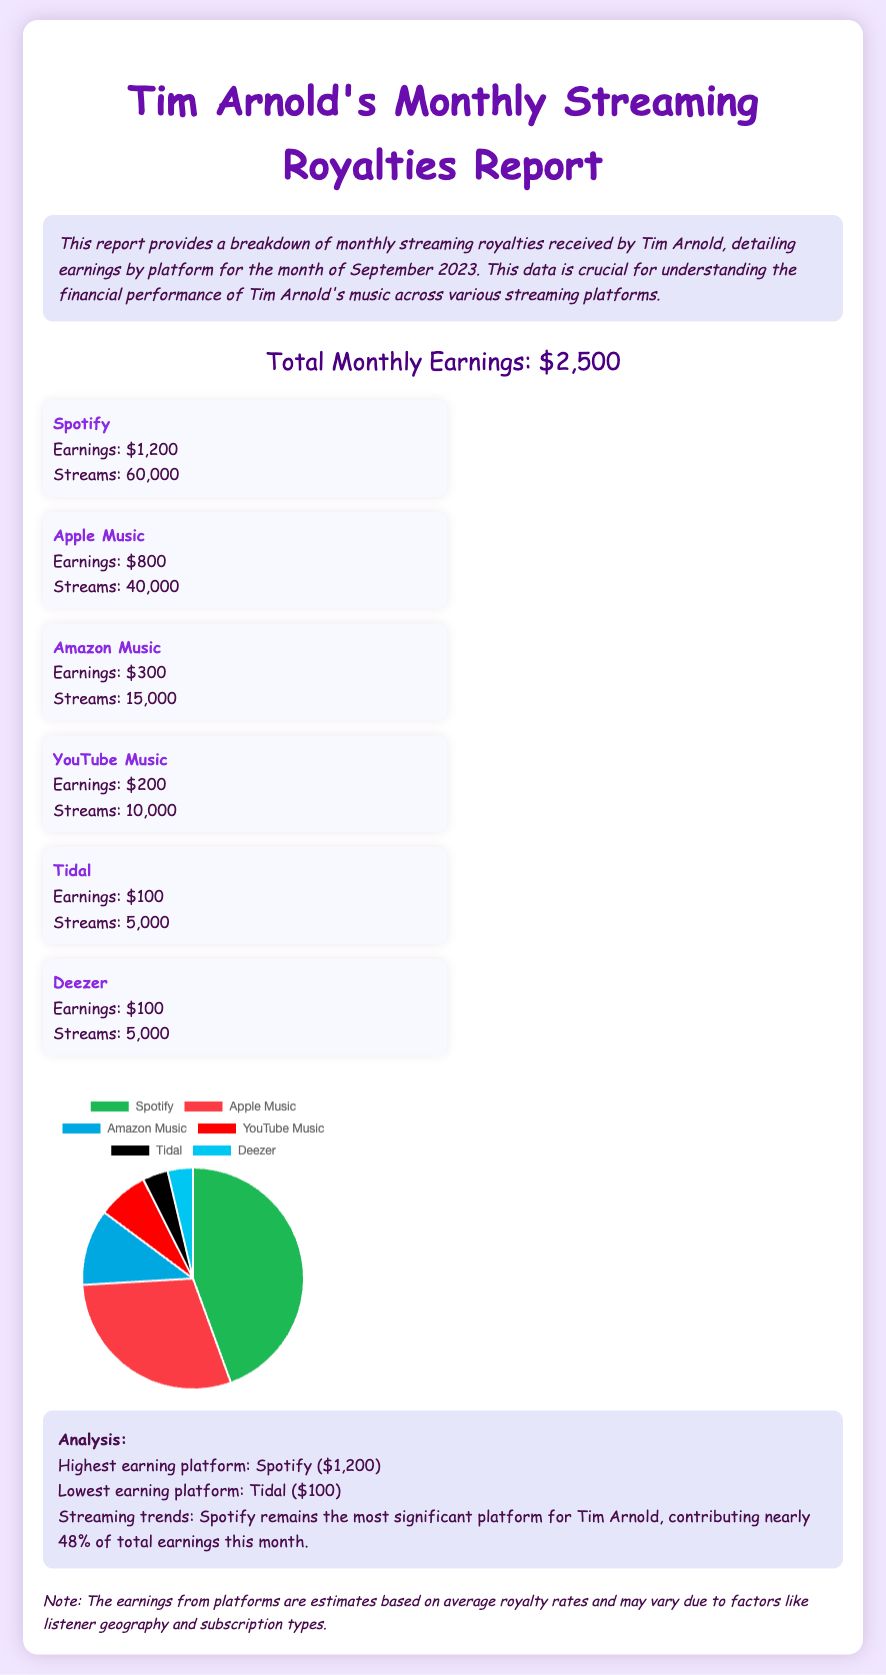What is the total monthly earnings? The total monthly earnings are listed at the top of the document, which states $2,500.
Answer: $2,500 Which platform has the highest earnings? The platform with the highest earnings is indicated in the analysis section as Spotify, with earnings of $1,200.
Answer: Spotify How many streams did Apple Music have? The number of streams for Apple Music is provided in the document as 40,000.
Answer: 40,000 What is the earnings amount from YouTube Music? The document lists the earnings from YouTube Music explicitly as $200.
Answer: $200 What percentage of total earnings does Spotify contribute? The analysis mentions that Spotify contributes nearly 48% of total earnings.
Answer: 48% Which platform had the lowest earnings? The lowest earning platform is highlighted in the analysis section as Tidal, which earned $100.
Answer: Tidal How many platforms are listed in the report? The report lists a total of six platforms as specified under the platform list section.
Answer: Six What is the total earnings from streaming platforms other than Spotify? By summing the earnings of the other platforms ($800 + $300 + $200 + $100 + $100), the total is calculated.
Answer: $1,600 How is the document styled? The document's style is described through its CSS, emphasizing a font of 'Comic Sans MS' and a background color of light lavender.
Answer: Comic Sans MS and lavender 